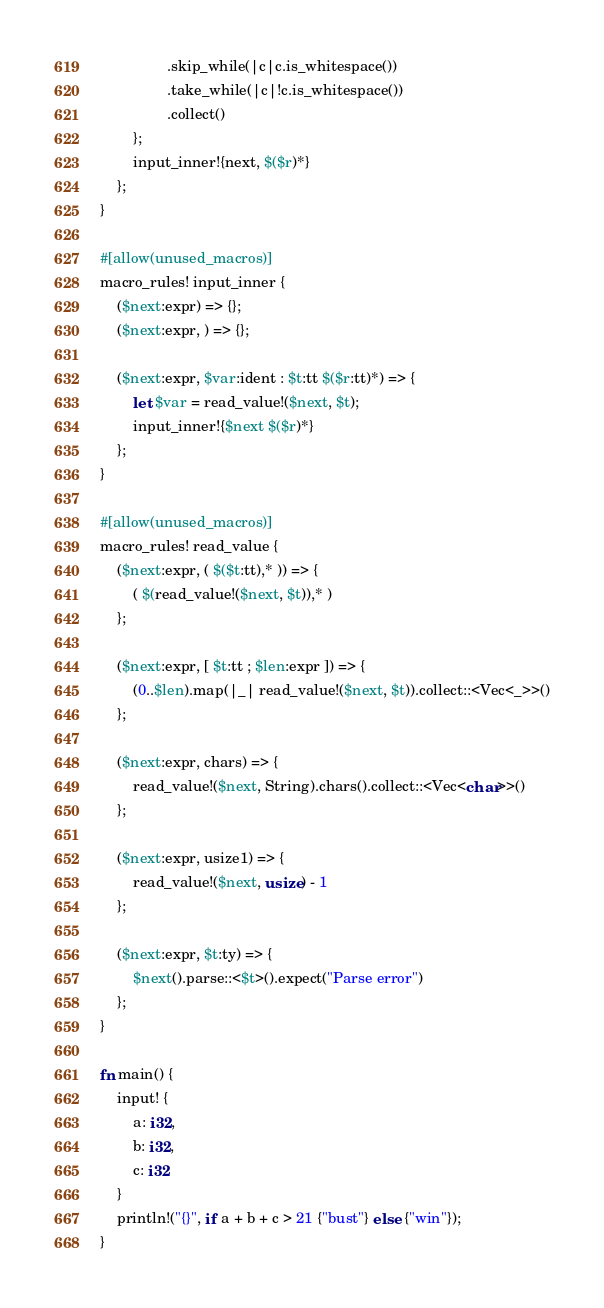<code> <loc_0><loc_0><loc_500><loc_500><_Rust_>                .skip_while(|c|c.is_whitespace())
                .take_while(|c|!c.is_whitespace())
                .collect()
        };
        input_inner!{next, $($r)*}
    };
}

#[allow(unused_macros)]
macro_rules! input_inner {
    ($next:expr) => {};
    ($next:expr, ) => {};

    ($next:expr, $var:ident : $t:tt $($r:tt)*) => {
        let $var = read_value!($next, $t);
        input_inner!{$next $($r)*}
    };
}

#[allow(unused_macros)]
macro_rules! read_value {
    ($next:expr, ( $($t:tt),* )) => {
        ( $(read_value!($next, $t)),* )
    };

    ($next:expr, [ $t:tt ; $len:expr ]) => {
        (0..$len).map(|_| read_value!($next, $t)).collect::<Vec<_>>()
    };

    ($next:expr, chars) => {
        read_value!($next, String).chars().collect::<Vec<char>>()
    };

    ($next:expr, usize1) => {
        read_value!($next, usize) - 1
    };

    ($next:expr, $t:ty) => {
        $next().parse::<$t>().expect("Parse error")
    };
}

fn main() {
    input! {
        a: i32,
        b: i32,
        c: i32
    }
    println!("{}", if a + b + c > 21 {"bust"} else {"win"});
}
</code> 